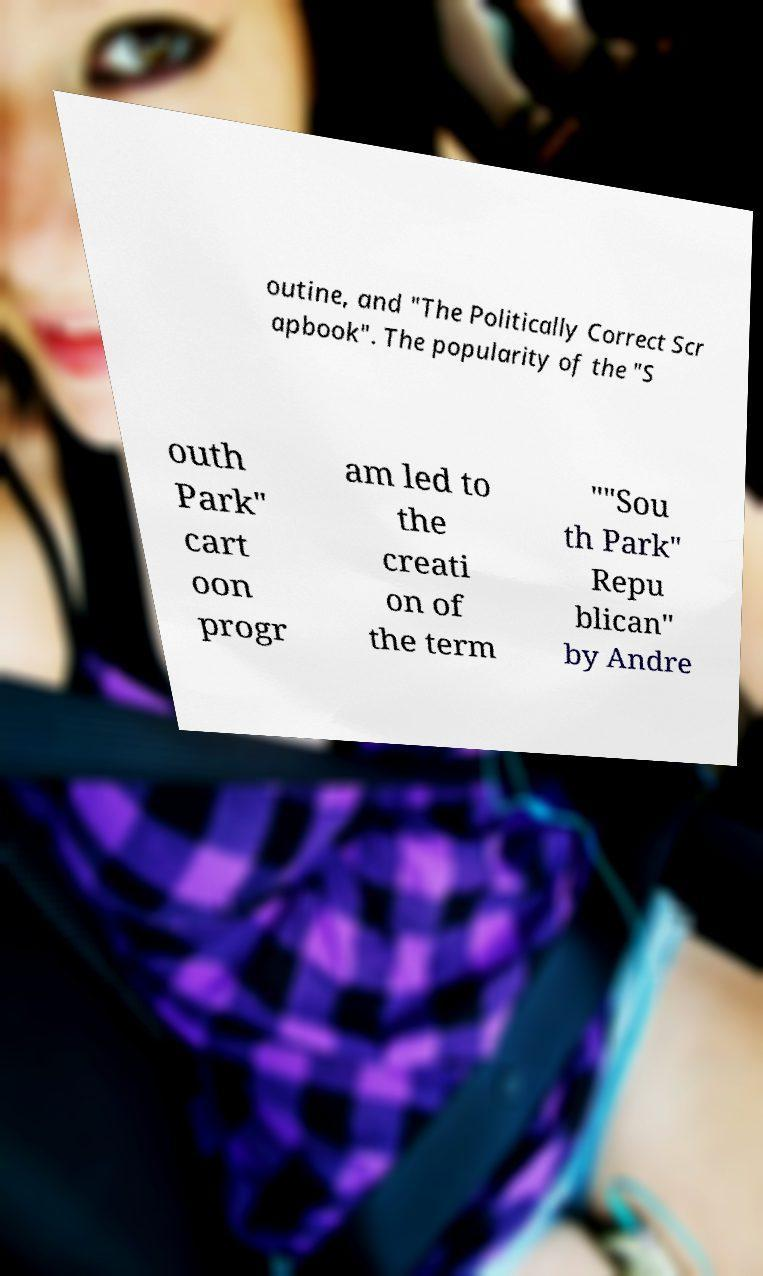Can you read and provide the text displayed in the image?This photo seems to have some interesting text. Can you extract and type it out for me? outine, and "The Politically Correct Scr apbook". The popularity of the "S outh Park" cart oon progr am led to the creati on of the term ""Sou th Park" Repu blican" by Andre 